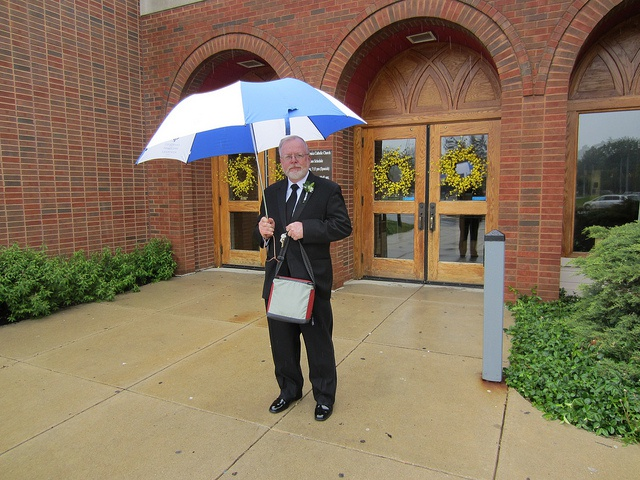Describe the objects in this image and their specific colors. I can see people in brown, black, darkgray, lightgray, and gray tones, umbrella in brown, white, lightblue, and blue tones, handbag in brown, lightgray, black, gray, and darkgray tones, car in brown, gray, and black tones, and tie in brown, black, and gray tones in this image. 